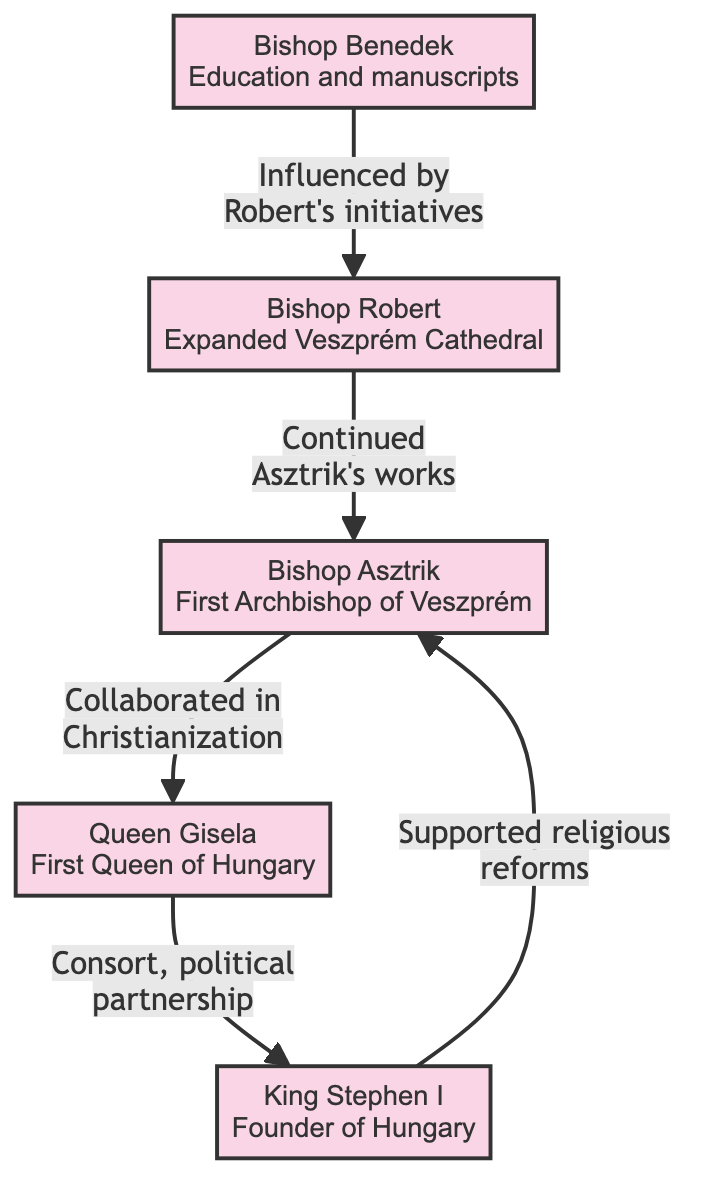What is the title of the first Archbishop of Veszprém? The title can be found in the diagram within the node representing Bishop Asztrik, which clearly states "First Archbishop of Veszprém".
Answer: First Archbishop of Veszprém How many historical figures are represented in the diagram? By counting the nodes in the diagram, we can identify there are five distinct figures: Bishop Asztrik, Queen Gisela, King Stephen I, Bishop Robert, and Bishop Benedek.
Answer: 5 Who is Queen Gisela's political partner? The diagram shows that Queen Gisela is linked to King Stephen I through a political partnership, which is explicitly written in the relationship line between them.
Answer: King Stephen I Which bishop continued the works of Bishop Asztrik? Referring to the diagram, Bishop Robert is indicated as the one who continued Asztrik's works, as described in the edge connecting the two nodes.
Answer: Bishop Robert What role did Bishop Benedek have in Veszprém's education? The edge connecting Bishop Benedek to Bishop Robert states that Benedek was influential in education and manuscripts, which reflects his role in Veszprém.
Answer: Education and manuscripts What does the diagram suggest about King Stephen I's actions towards religious reforms? The diagram indicates that King Stephen I supported religious reforms, as noted in the relationship between him and Bishop Asztrik.
Answer: Supported religious reforms Who was the first queen of Hungary? The node for Queen Gisela explicitly names her as the "First Queen of Hungary".
Answer: First Queen of Hungary What relationship exists between Bishop Robert and Bishop Benedek? The diagram illustrates that Bishop Benedek was influenced by Robert's initiatives, indicating a directed relationship stemming from Robert's contributions.
Answer: Influenced by Robert's initiatives 